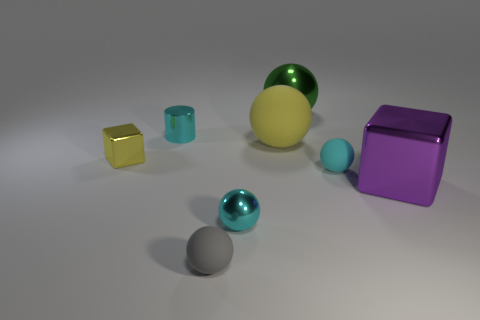Subtract all tiny spheres. How many spheres are left? 2 Subtract all red cylinders. How many cyan balls are left? 2 Subtract all cyan spheres. How many spheres are left? 3 Add 2 big green shiny balls. How many objects exist? 10 Subtract all blocks. How many objects are left? 6 Subtract all cyan balls. Subtract all blue cylinders. How many balls are left? 3 Subtract all tiny gray rubber cubes. Subtract all small gray matte spheres. How many objects are left? 7 Add 5 cubes. How many cubes are left? 7 Add 6 tiny yellow matte things. How many tiny yellow matte things exist? 6 Subtract 2 cyan spheres. How many objects are left? 6 